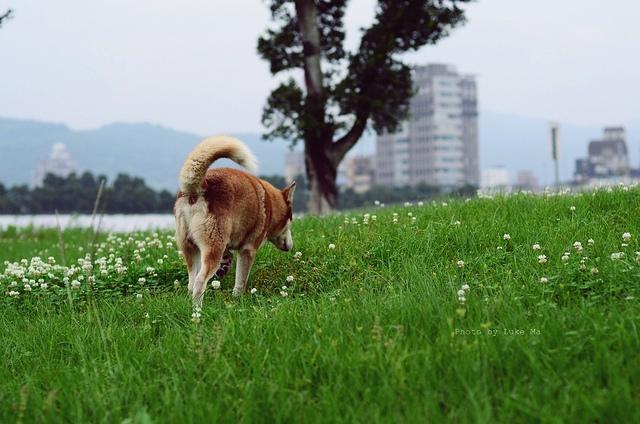Is it daytime?
Concise answer only. Yes. How far away is the town in the left of the picture?
Be succinct. 1 mile. What is growing in the grass?
Write a very short answer. Flowers. What is the dog doing?
Write a very short answer. Walking. Is this in a zoo?
Give a very brief answer. No. Where is the dog walking?
Write a very short answer. Grass. Sunny or overcast?
Concise answer only. Overcast. What color are the flowers in the image?
Keep it brief. White. 